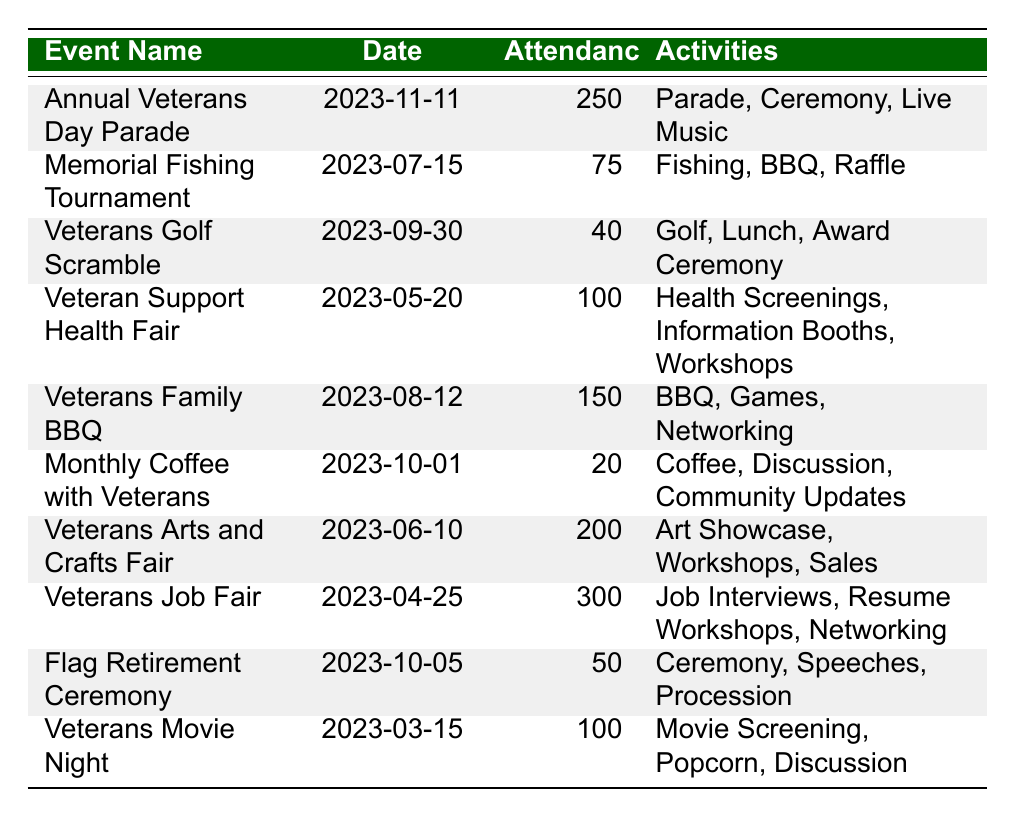What is the attendance for the Annual Veterans Day Parade? The table shows that the attendance for the Annual Veterans Day Parade is listed under the attendance column. It is explicitly stated as 250.
Answer: 250 What date is the Veterans Job Fair scheduled for? By examining the date column in the table, the date for the Veterans Job Fair is provided directly, which is 2023-04-25.
Answer: 2023-04-25 How many attendees were at the Veterans Golf Scramble? Looking at the attendance column corresponding to the Veterans Golf Scramble, the number of attendees is clearly noted as 40.
Answer: 40 Which event had the highest attendance? Scanning through the attendance column reveals the highest number, which is 300 for the Veterans Job Fair.
Answer: Veterans Job Fair How many total attendees were there across all events listed? To find the total, we sum the attendance values: 250 + 75 + 40 + 100 + 150 + 20 + 200 + 300 + 50 + 100 = 1,185.
Answer: 1185 What is the average attendance for the events? The total attendance is 1,185, and there are 10 events. Average attendance = 1,185 / 10 = 118.5.
Answer: 118.5 Did the Memorial Fishing Tournament have more attendees than the Veterans Golf Scramble? Comparing the attendance numbers, the Memorial Fishing Tournament has 75 attendees while the Veterans Golf Scramble has 40. Since 75 is greater than 40, the answer is yes.
Answer: Yes Which event focused on artists and crafts? The table lists "Veterans Arts and Crafts Fair" under the event name, clearly indicating it is dedicated to art and crafts.
Answer: Veterans Arts and Crafts Fair Which two events had an attendance of 100 or more? Scanning the attendance column, the events with 100 or more attendees are the Veterans Job Fair (300) and the Veterans Arts and Crafts Fair (200).
Answer: Veterans Job Fair, Veterans Arts and Crafts Fair Is there an event scheduled for October? Checking the date column shows two events in October: Monthly Coffee with Veterans (2023-10-01) and Flag Retirement Ceremony (2023-10-05). Therefore, yes, there are events scheduled for October.
Answer: Yes 